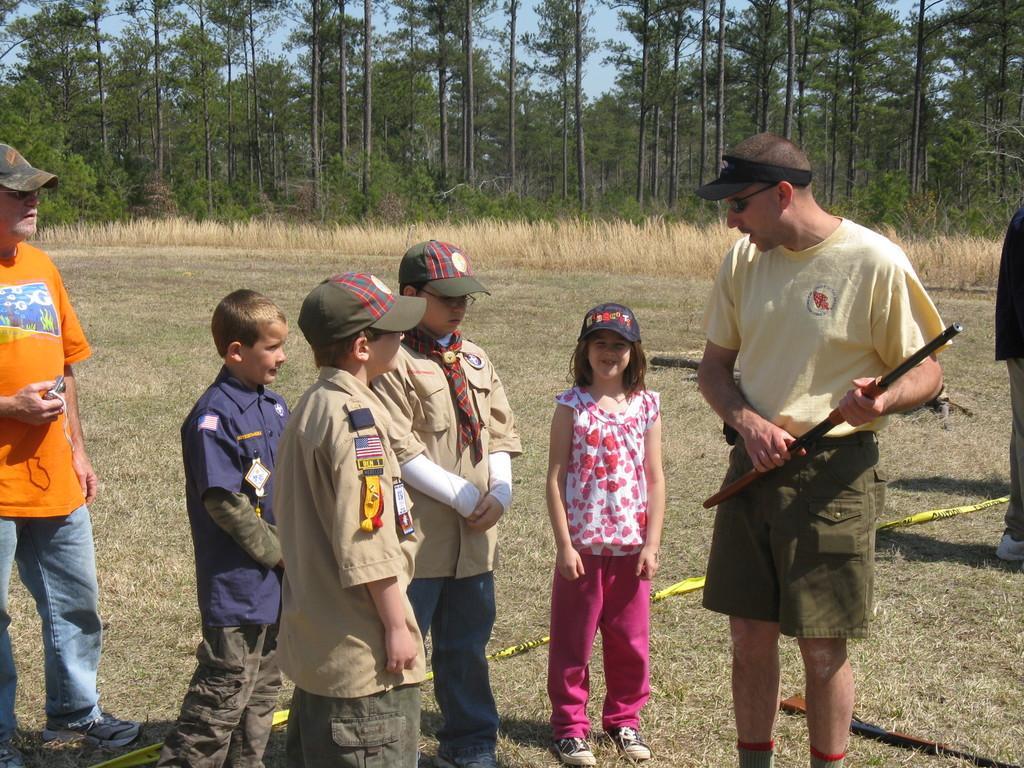In one or two sentences, can you explain what this image depicts? In the center of the image there are kids standing. There is a person holding a stick in his hand. In the background of the image there are trees. At the bottom of the image there is grass. 